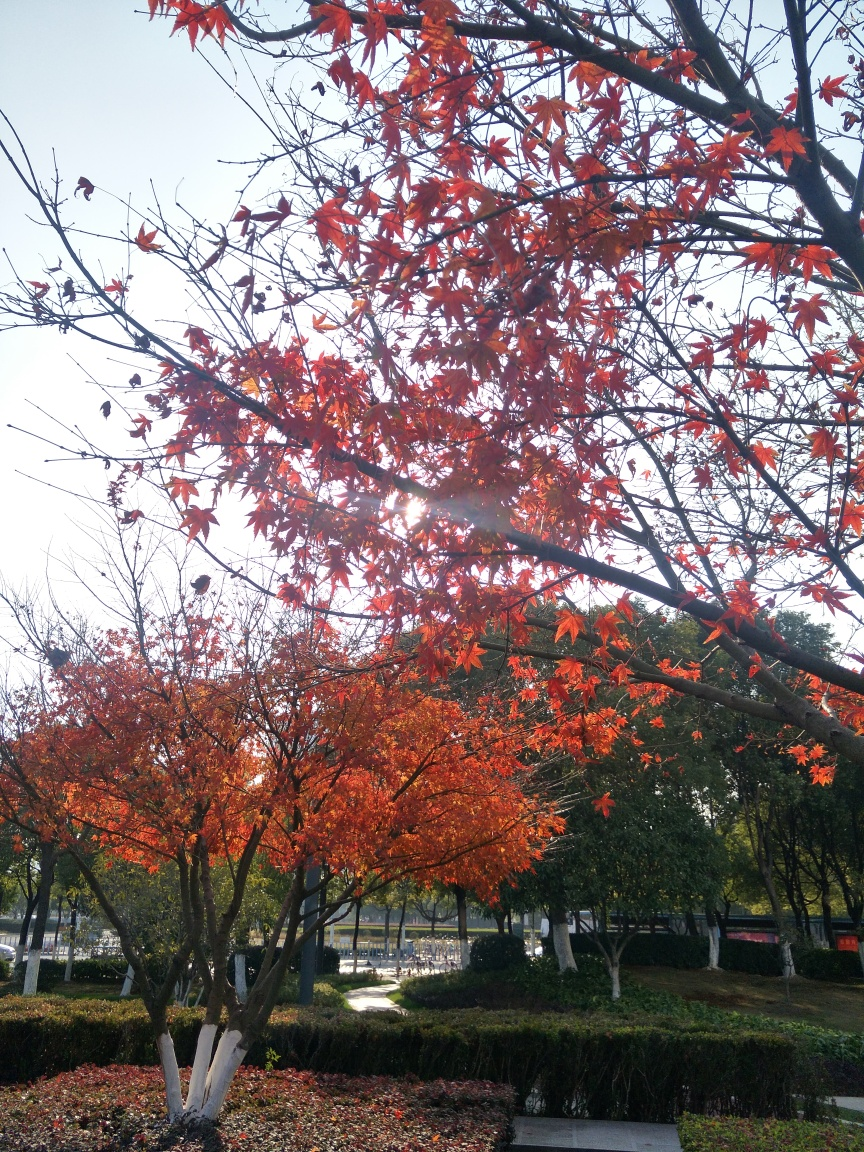What is the lighting like in the image? The lighting in the image appears soft and natural, likely from a gentle sun filtering through the autumn leaves. The angle of the light creates subtle shadows and highlights the vivid red and orange hues of the foliage, suggesting it could be early morning or late afternoon. 